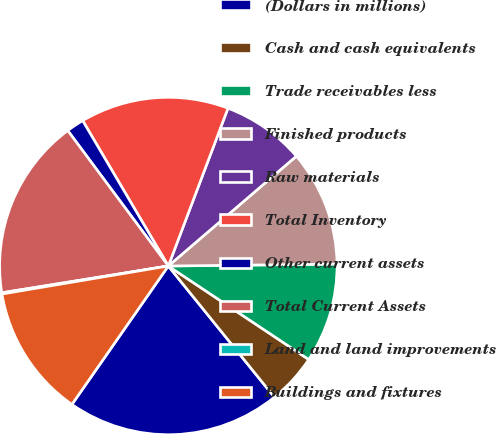Convert chart to OTSL. <chart><loc_0><loc_0><loc_500><loc_500><pie_chart><fcel>(Dollars in millions)<fcel>Cash and cash equivalents<fcel>Trade receivables less<fcel>Finished products<fcel>Raw materials<fcel>Total Inventory<fcel>Other current assets<fcel>Total Current Assets<fcel>Land and land improvements<fcel>Buildings and fixtures<nl><fcel>20.5%<fcel>4.83%<fcel>9.53%<fcel>11.1%<fcel>7.96%<fcel>14.23%<fcel>1.69%<fcel>17.37%<fcel>0.12%<fcel>12.66%<nl></chart> 